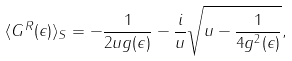Convert formula to latex. <formula><loc_0><loc_0><loc_500><loc_500>\langle G ^ { R } ( \epsilon ) \rangle _ { S } = - \frac { 1 } { 2 u g ( \epsilon ) } - \frac { i } { u } \sqrt { u - \frac { 1 } { 4 g ^ { 2 } ( \epsilon ) } } ,</formula> 